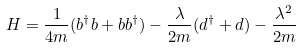Convert formula to latex. <formula><loc_0><loc_0><loc_500><loc_500>H = \frac { 1 } { 4 m } ( b ^ { \dagger } b + b b ^ { \dagger } ) - \frac { \lambda } { 2 m } ( d ^ { \dagger } + d ) - \frac { \lambda ^ { 2 } } { 2 m }</formula> 